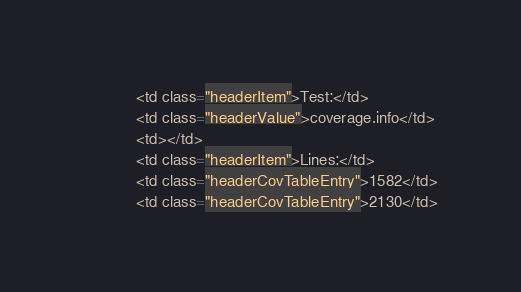Convert code to text. <code><loc_0><loc_0><loc_500><loc_500><_HTML_>            <td class="headerItem">Test:</td>
            <td class="headerValue">coverage.info</td>
            <td></td>
            <td class="headerItem">Lines:</td>
            <td class="headerCovTableEntry">1582</td>
            <td class="headerCovTableEntry">2130</td></code> 